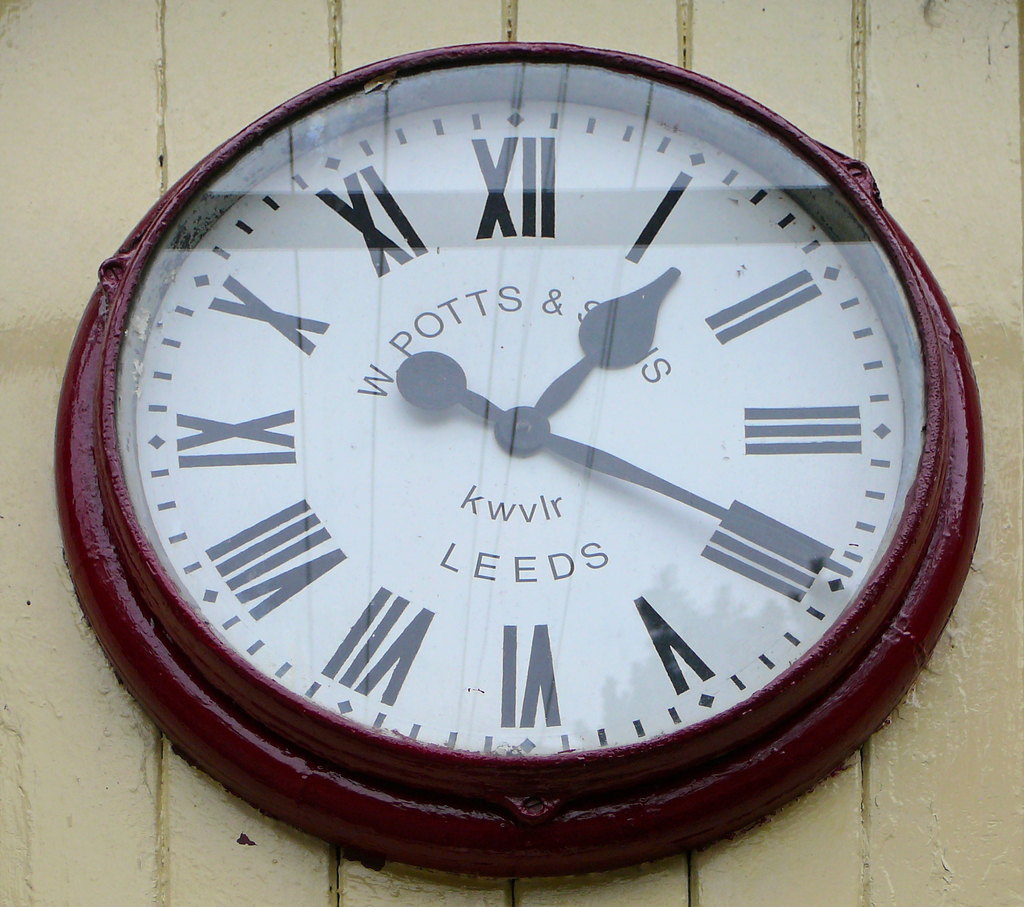Could there be a historical significance to this clock in Leeds, IA? Indeed, the A. W. Potts & Sons clock in Leeds, IA, might hold historical significance as a local landmark, serving both a practical function and as a testament to the craftsmanship and heritage of the area, often becoming a point of reference in the community's history and daily life. 